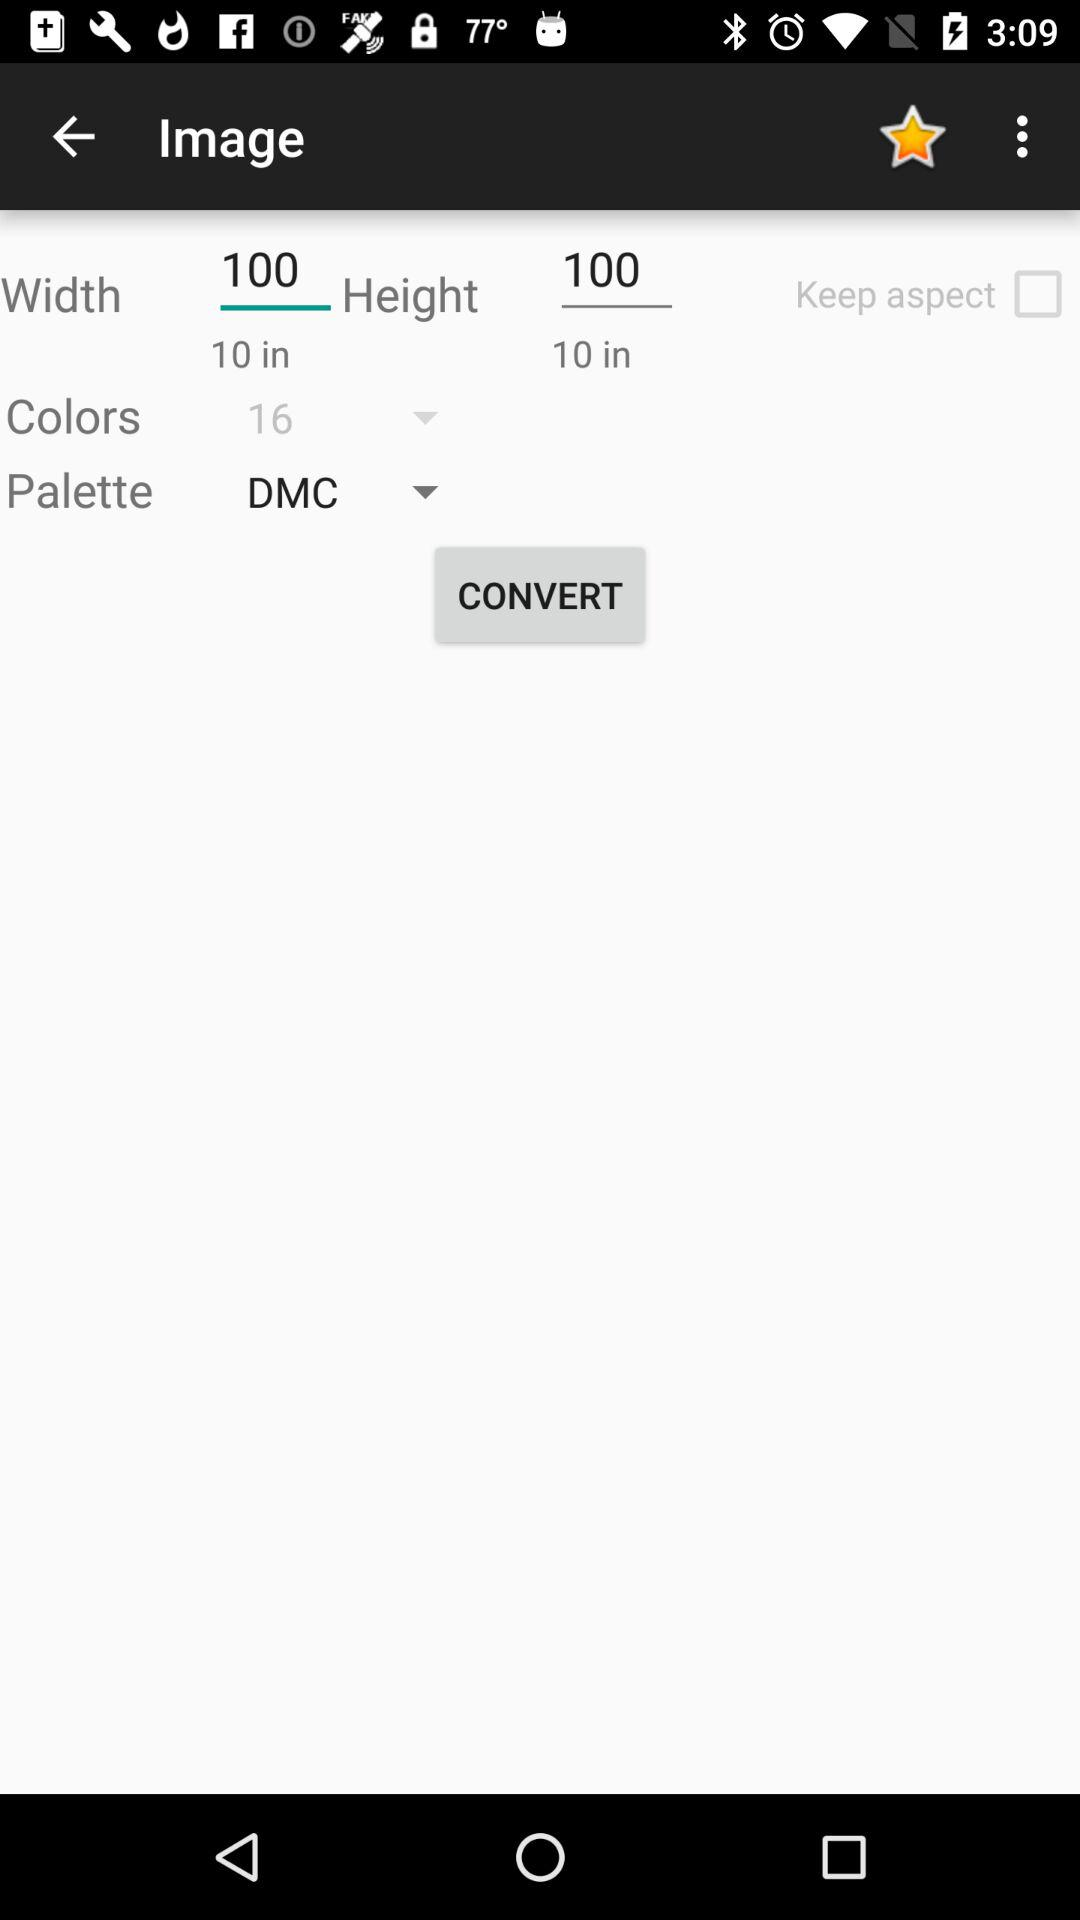How many colors are available?
Answer the question using a single word or phrase. 16 